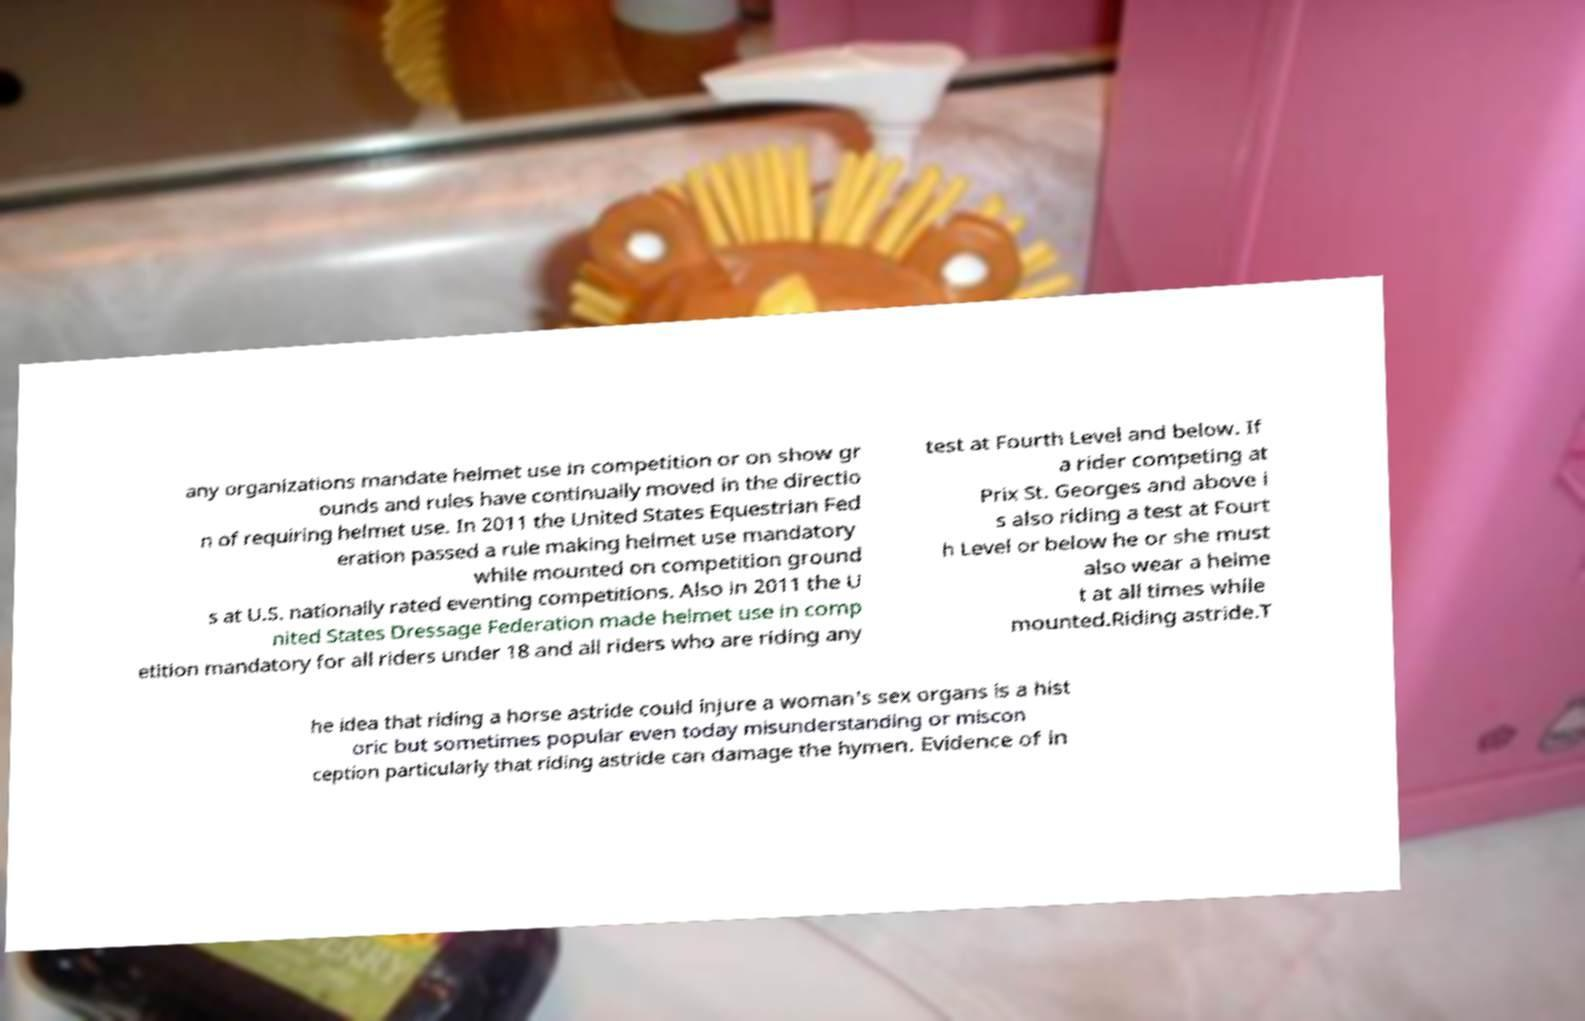There's text embedded in this image that I need extracted. Can you transcribe it verbatim? any organizations mandate helmet use in competition or on show gr ounds and rules have continually moved in the directio n of requiring helmet use. In 2011 the United States Equestrian Fed eration passed a rule making helmet use mandatory while mounted on competition ground s at U.S. nationally rated eventing competitions. Also in 2011 the U nited States Dressage Federation made helmet use in comp etition mandatory for all riders under 18 and all riders who are riding any test at Fourth Level and below. If a rider competing at Prix St. Georges and above i s also riding a test at Fourt h Level or below he or she must also wear a helme t at all times while mounted.Riding astride.T he idea that riding a horse astride could injure a woman's sex organs is a hist oric but sometimes popular even today misunderstanding or miscon ception particularly that riding astride can damage the hymen. Evidence of in 